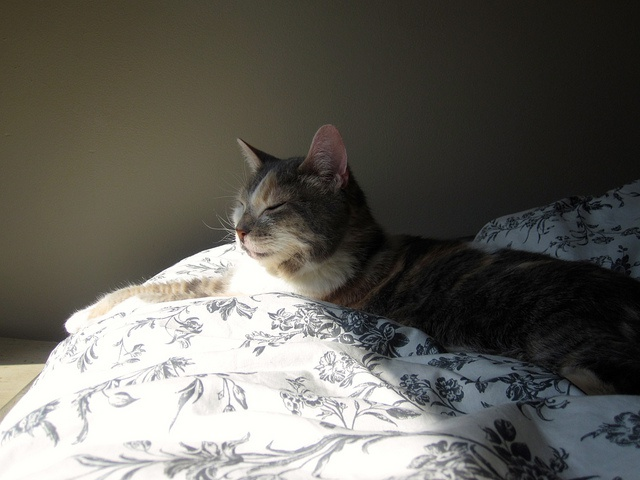Describe the objects in this image and their specific colors. I can see bed in black, white, gray, and darkgray tones and cat in black, gray, and ivory tones in this image. 